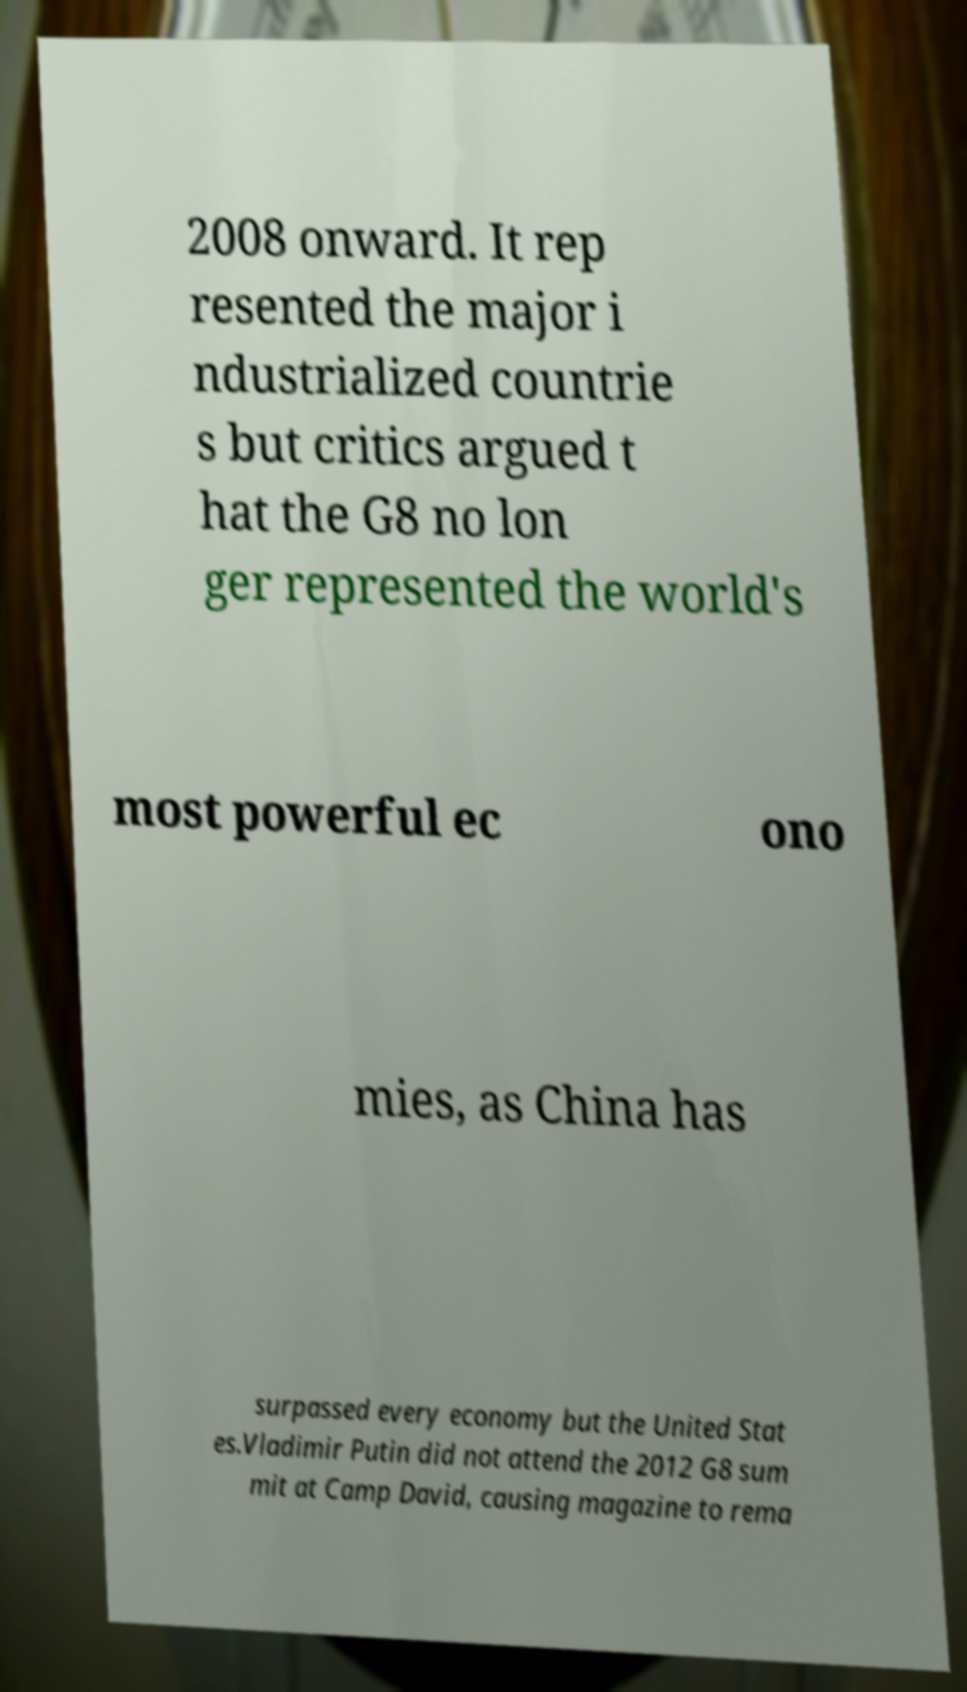For documentation purposes, I need the text within this image transcribed. Could you provide that? 2008 onward. It rep resented the major i ndustrialized countrie s but critics argued t hat the G8 no lon ger represented the world's most powerful ec ono mies, as China has surpassed every economy but the United Stat es.Vladimir Putin did not attend the 2012 G8 sum mit at Camp David, causing magazine to rema 